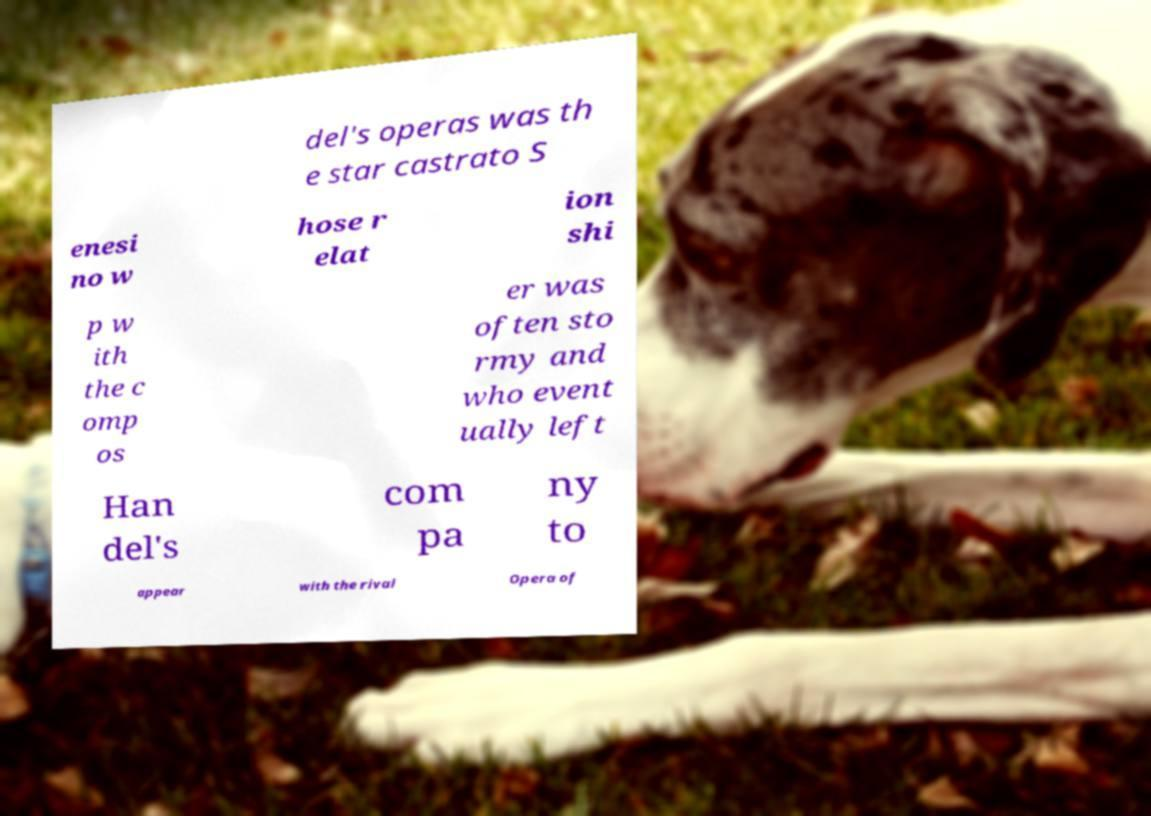I need the written content from this picture converted into text. Can you do that? del's operas was th e star castrato S enesi no w hose r elat ion shi p w ith the c omp os er was often sto rmy and who event ually left Han del's com pa ny to appear with the rival Opera of 